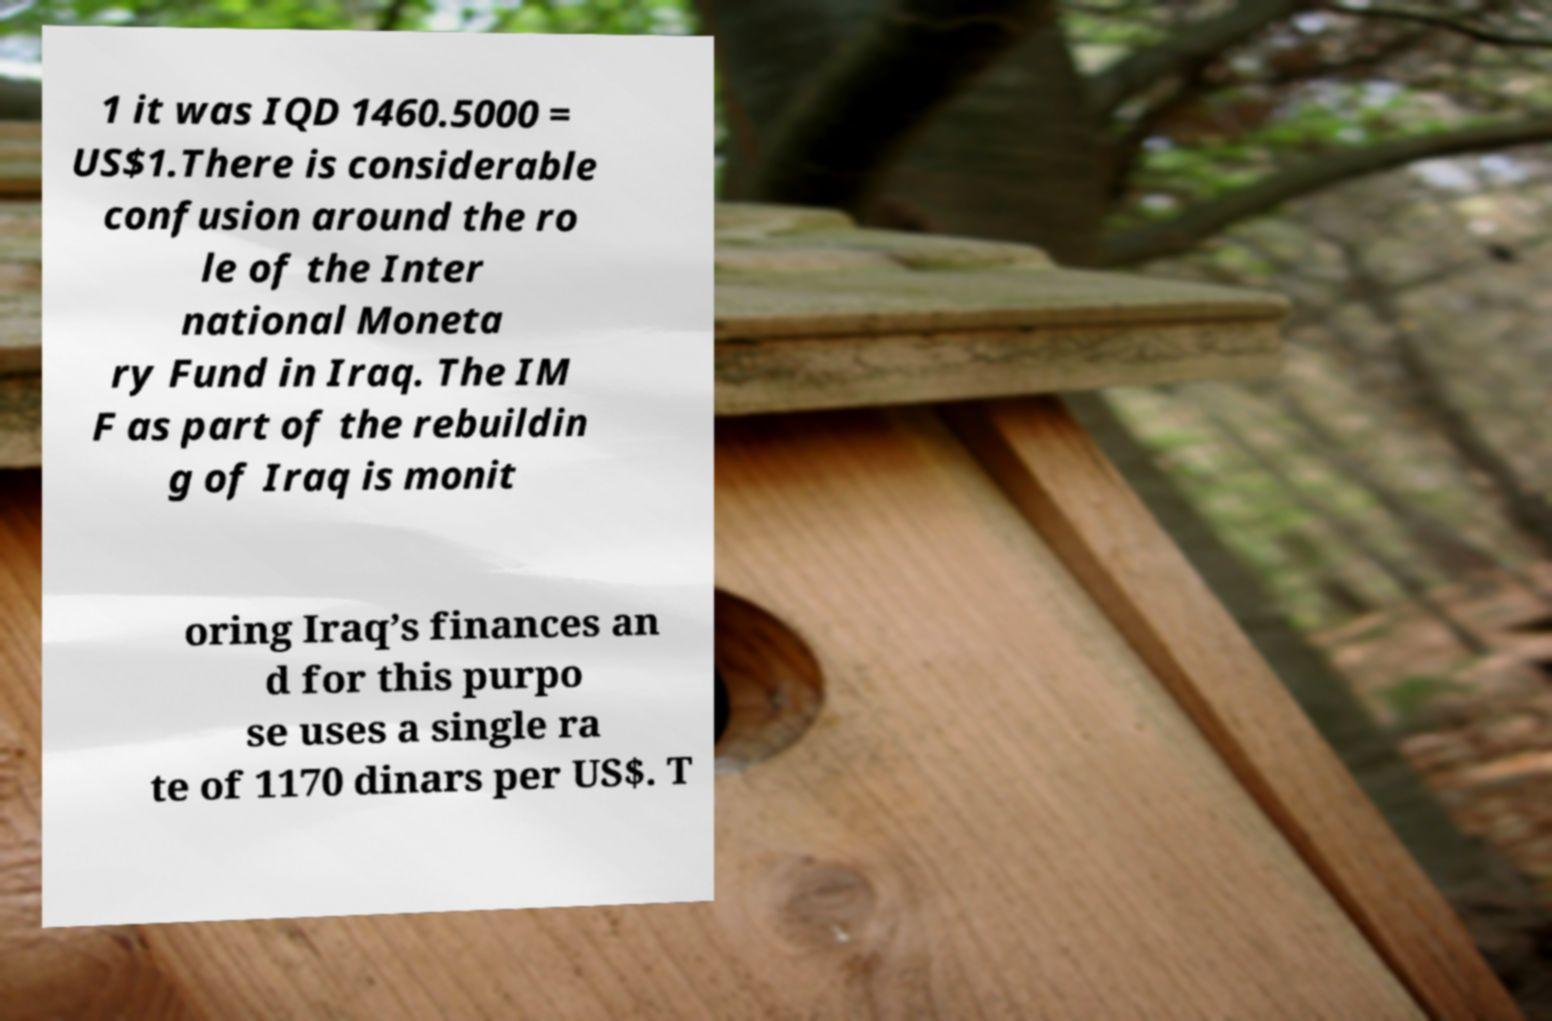Please read and relay the text visible in this image. What does it say? 1 it was IQD 1460.5000 = US$1.There is considerable confusion around the ro le of the Inter national Moneta ry Fund in Iraq. The IM F as part of the rebuildin g of Iraq is monit oring Iraq’s finances an d for this purpo se uses a single ra te of 1170 dinars per US$. T 